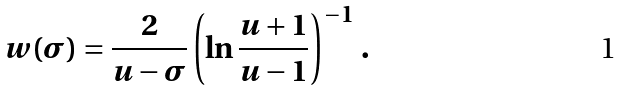<formula> <loc_0><loc_0><loc_500><loc_500>w ( \sigma ) = \frac { 2 } { u - \sigma } \left ( \ln \frac { u + 1 } { u - 1 } \right ) ^ { - 1 } \, .</formula> 